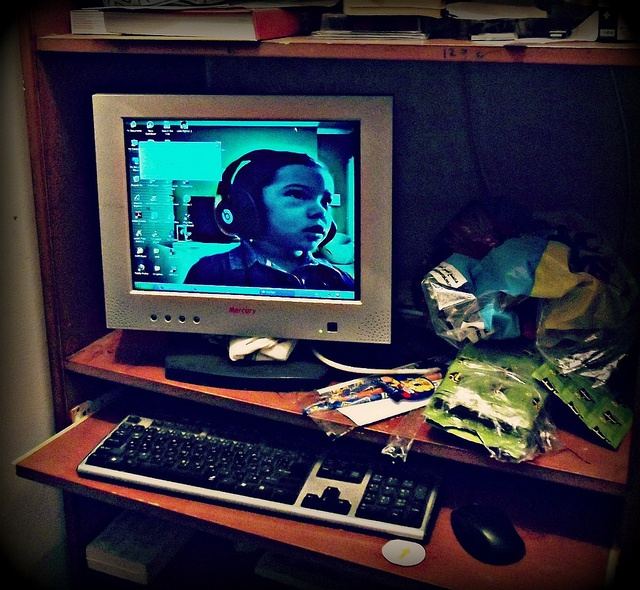Describe the objects in this image and their specific colors. I can see tv in black, gray, navy, and turquoise tones, keyboard in black, navy, and tan tones, people in black, navy, blue, and teal tones, and mouse in black, gray, purple, and tan tones in this image. 